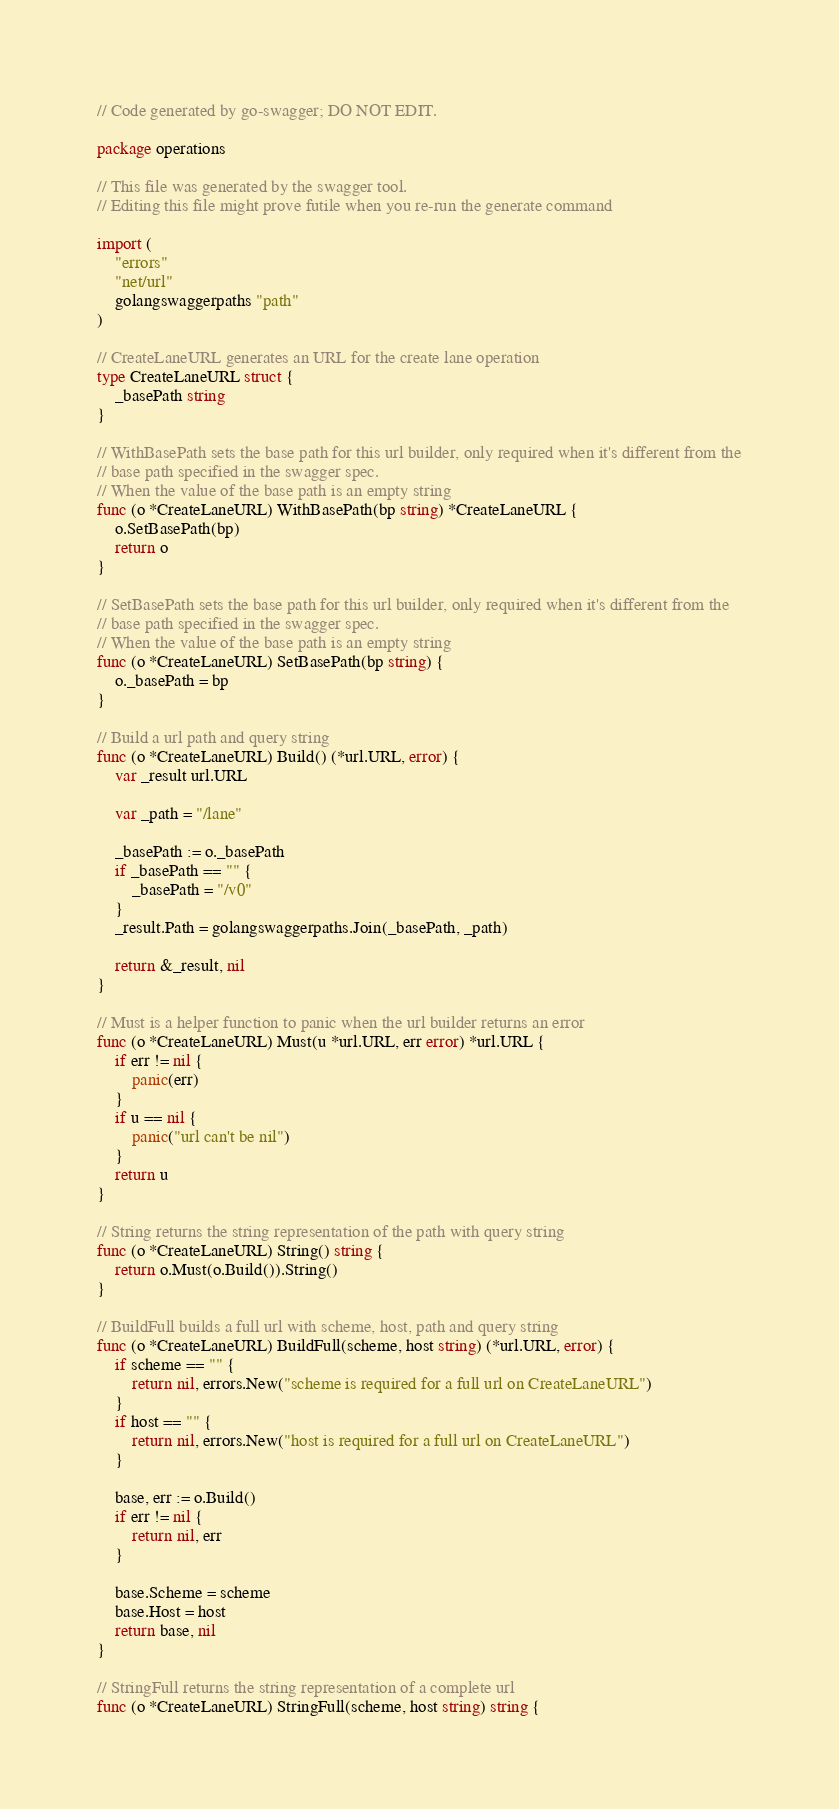Convert code to text. <code><loc_0><loc_0><loc_500><loc_500><_Go_>// Code generated by go-swagger; DO NOT EDIT.

package operations

// This file was generated by the swagger tool.
// Editing this file might prove futile when you re-run the generate command

import (
	"errors"
	"net/url"
	golangswaggerpaths "path"
)

// CreateLaneURL generates an URL for the create lane operation
type CreateLaneURL struct {
	_basePath string
}

// WithBasePath sets the base path for this url builder, only required when it's different from the
// base path specified in the swagger spec.
// When the value of the base path is an empty string
func (o *CreateLaneURL) WithBasePath(bp string) *CreateLaneURL {
	o.SetBasePath(bp)
	return o
}

// SetBasePath sets the base path for this url builder, only required when it's different from the
// base path specified in the swagger spec.
// When the value of the base path is an empty string
func (o *CreateLaneURL) SetBasePath(bp string) {
	o._basePath = bp
}

// Build a url path and query string
func (o *CreateLaneURL) Build() (*url.URL, error) {
	var _result url.URL

	var _path = "/lane"

	_basePath := o._basePath
	if _basePath == "" {
		_basePath = "/v0"
	}
	_result.Path = golangswaggerpaths.Join(_basePath, _path)

	return &_result, nil
}

// Must is a helper function to panic when the url builder returns an error
func (o *CreateLaneURL) Must(u *url.URL, err error) *url.URL {
	if err != nil {
		panic(err)
	}
	if u == nil {
		panic("url can't be nil")
	}
	return u
}

// String returns the string representation of the path with query string
func (o *CreateLaneURL) String() string {
	return o.Must(o.Build()).String()
}

// BuildFull builds a full url with scheme, host, path and query string
func (o *CreateLaneURL) BuildFull(scheme, host string) (*url.URL, error) {
	if scheme == "" {
		return nil, errors.New("scheme is required for a full url on CreateLaneURL")
	}
	if host == "" {
		return nil, errors.New("host is required for a full url on CreateLaneURL")
	}

	base, err := o.Build()
	if err != nil {
		return nil, err
	}

	base.Scheme = scheme
	base.Host = host
	return base, nil
}

// StringFull returns the string representation of a complete url
func (o *CreateLaneURL) StringFull(scheme, host string) string {</code> 